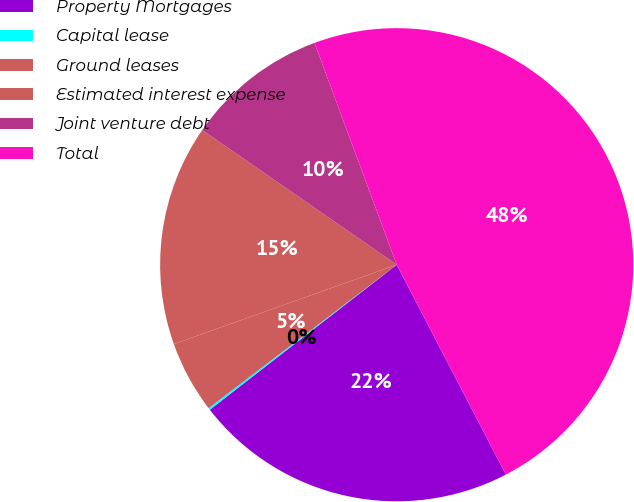<chart> <loc_0><loc_0><loc_500><loc_500><pie_chart><fcel>Property Mortgages<fcel>Capital lease<fcel>Ground leases<fcel>Estimated interest expense<fcel>Joint venture debt<fcel>Total<nl><fcel>22.13%<fcel>0.14%<fcel>4.92%<fcel>15.09%<fcel>9.71%<fcel>48.02%<nl></chart> 